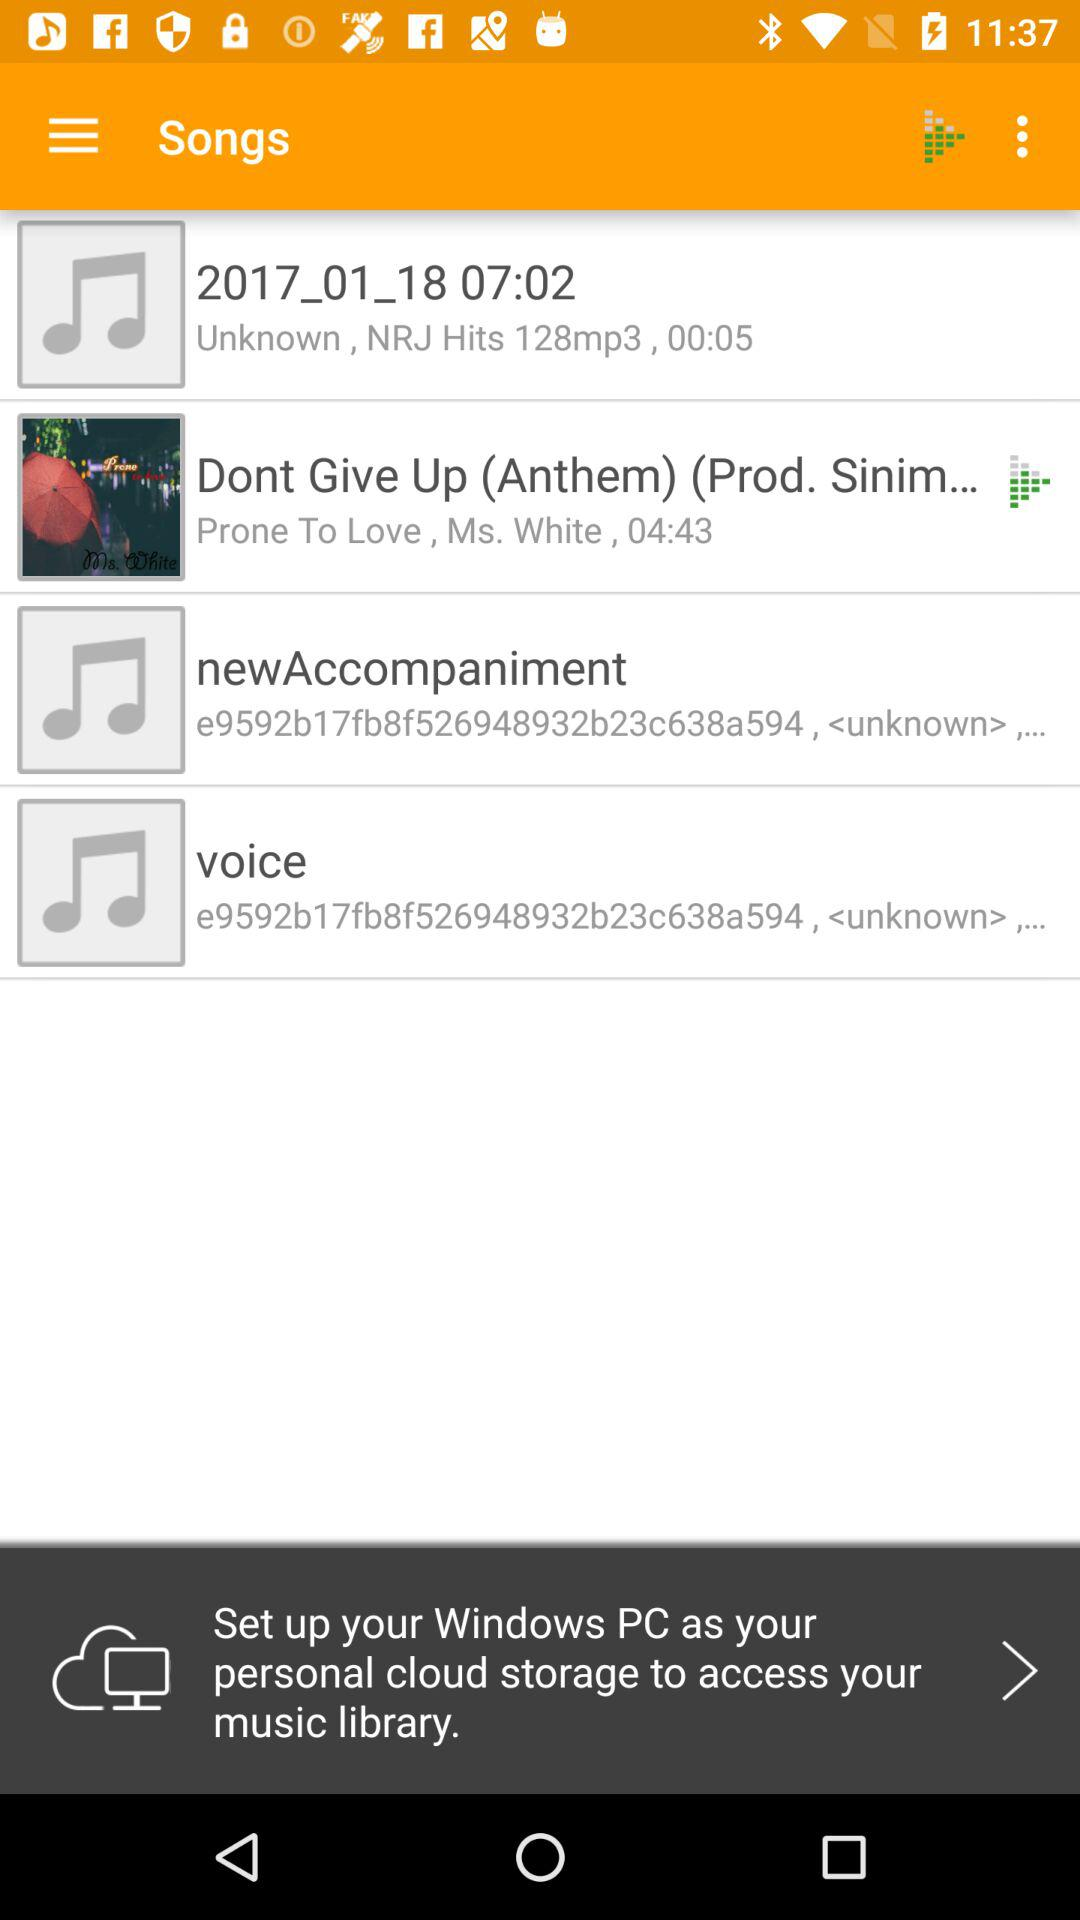What is the duration of "Don't Give Up (Anthem)"? The duration is 04:43. 